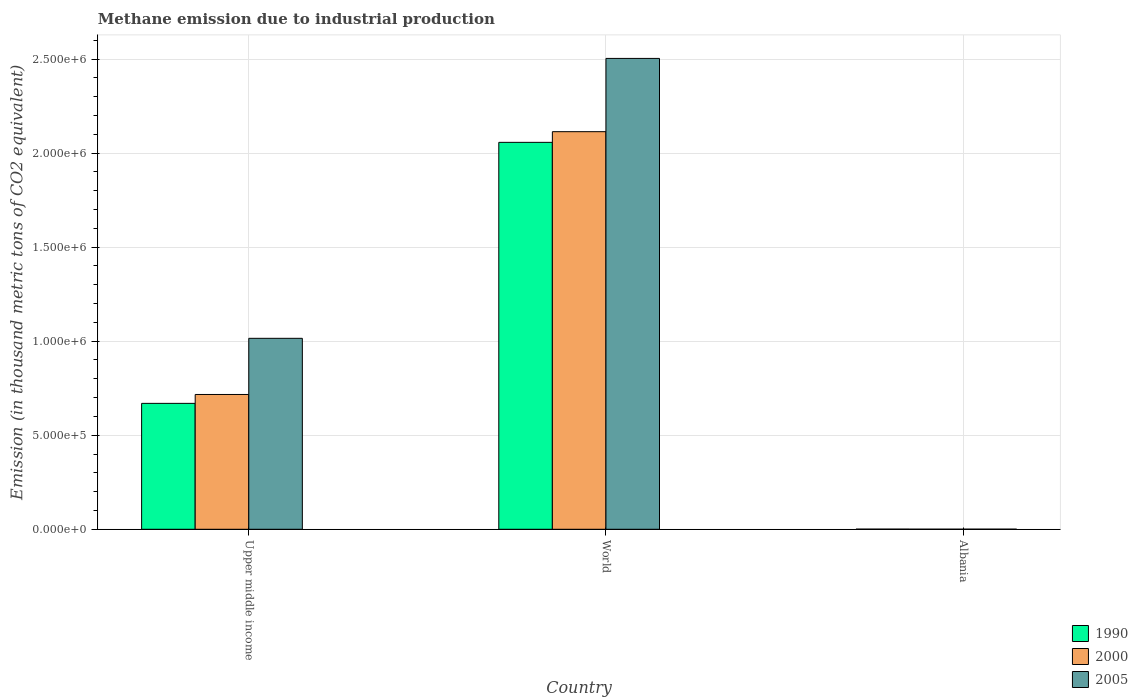How many groups of bars are there?
Keep it short and to the point. 3. How many bars are there on the 1st tick from the left?
Offer a very short reply. 3. What is the label of the 3rd group of bars from the left?
Your answer should be compact. Albania. In how many cases, is the number of bars for a given country not equal to the number of legend labels?
Provide a short and direct response. 0. What is the amount of methane emitted in 2000 in Upper middle income?
Keep it short and to the point. 7.17e+05. Across all countries, what is the maximum amount of methane emitted in 1990?
Your response must be concise. 2.06e+06. Across all countries, what is the minimum amount of methane emitted in 2005?
Your response must be concise. 550.9. In which country was the amount of methane emitted in 2000 minimum?
Give a very brief answer. Albania. What is the total amount of methane emitted in 2005 in the graph?
Your response must be concise. 3.52e+06. What is the difference between the amount of methane emitted in 2005 in Albania and that in Upper middle income?
Your answer should be very brief. -1.01e+06. What is the difference between the amount of methane emitted in 2005 in World and the amount of methane emitted in 1990 in Albania?
Your answer should be compact. 2.50e+06. What is the average amount of methane emitted in 2000 per country?
Give a very brief answer. 9.44e+05. What is the difference between the amount of methane emitted of/in 2000 and amount of methane emitted of/in 1990 in Upper middle income?
Your answer should be compact. 4.72e+04. In how many countries, is the amount of methane emitted in 1990 greater than 800000 thousand metric tons?
Provide a short and direct response. 1. What is the ratio of the amount of methane emitted in 1990 in Upper middle income to that in World?
Provide a short and direct response. 0.33. Is the amount of methane emitted in 2005 in Albania less than that in Upper middle income?
Provide a succinct answer. Yes. Is the difference between the amount of methane emitted in 2000 in Albania and World greater than the difference between the amount of methane emitted in 1990 in Albania and World?
Your answer should be compact. No. What is the difference between the highest and the second highest amount of methane emitted in 2000?
Your answer should be compact. -2.11e+06. What is the difference between the highest and the lowest amount of methane emitted in 2005?
Give a very brief answer. 2.50e+06. What does the 2nd bar from the right in World represents?
Offer a very short reply. 2000. Is it the case that in every country, the sum of the amount of methane emitted in 1990 and amount of methane emitted in 2000 is greater than the amount of methane emitted in 2005?
Make the answer very short. Yes. Are all the bars in the graph horizontal?
Ensure brevity in your answer.  No. Does the graph contain any zero values?
Your response must be concise. No. Where does the legend appear in the graph?
Keep it short and to the point. Bottom right. How are the legend labels stacked?
Ensure brevity in your answer.  Vertical. What is the title of the graph?
Ensure brevity in your answer.  Methane emission due to industrial production. What is the label or title of the X-axis?
Your response must be concise. Country. What is the label or title of the Y-axis?
Provide a short and direct response. Emission (in thousand metric tons of CO2 equivalent). What is the Emission (in thousand metric tons of CO2 equivalent) of 1990 in Upper middle income?
Your answer should be compact. 6.69e+05. What is the Emission (in thousand metric tons of CO2 equivalent) of 2000 in Upper middle income?
Provide a short and direct response. 7.17e+05. What is the Emission (in thousand metric tons of CO2 equivalent) of 2005 in Upper middle income?
Your answer should be compact. 1.02e+06. What is the Emission (in thousand metric tons of CO2 equivalent) of 1990 in World?
Make the answer very short. 2.06e+06. What is the Emission (in thousand metric tons of CO2 equivalent) in 2000 in World?
Offer a terse response. 2.11e+06. What is the Emission (in thousand metric tons of CO2 equivalent) of 2005 in World?
Offer a very short reply. 2.50e+06. What is the Emission (in thousand metric tons of CO2 equivalent) in 1990 in Albania?
Provide a short and direct response. 789.5. What is the Emission (in thousand metric tons of CO2 equivalent) in 2000 in Albania?
Offer a very short reply. 383.4. What is the Emission (in thousand metric tons of CO2 equivalent) of 2005 in Albania?
Your answer should be compact. 550.9. Across all countries, what is the maximum Emission (in thousand metric tons of CO2 equivalent) of 1990?
Your answer should be very brief. 2.06e+06. Across all countries, what is the maximum Emission (in thousand metric tons of CO2 equivalent) of 2000?
Ensure brevity in your answer.  2.11e+06. Across all countries, what is the maximum Emission (in thousand metric tons of CO2 equivalent) of 2005?
Provide a short and direct response. 2.50e+06. Across all countries, what is the minimum Emission (in thousand metric tons of CO2 equivalent) in 1990?
Your response must be concise. 789.5. Across all countries, what is the minimum Emission (in thousand metric tons of CO2 equivalent) of 2000?
Your response must be concise. 383.4. Across all countries, what is the minimum Emission (in thousand metric tons of CO2 equivalent) of 2005?
Your response must be concise. 550.9. What is the total Emission (in thousand metric tons of CO2 equivalent) of 1990 in the graph?
Give a very brief answer. 2.73e+06. What is the total Emission (in thousand metric tons of CO2 equivalent) of 2000 in the graph?
Offer a terse response. 2.83e+06. What is the total Emission (in thousand metric tons of CO2 equivalent) of 2005 in the graph?
Give a very brief answer. 3.52e+06. What is the difference between the Emission (in thousand metric tons of CO2 equivalent) of 1990 in Upper middle income and that in World?
Your response must be concise. -1.39e+06. What is the difference between the Emission (in thousand metric tons of CO2 equivalent) of 2000 in Upper middle income and that in World?
Ensure brevity in your answer.  -1.40e+06. What is the difference between the Emission (in thousand metric tons of CO2 equivalent) in 2005 in Upper middle income and that in World?
Provide a short and direct response. -1.49e+06. What is the difference between the Emission (in thousand metric tons of CO2 equivalent) of 1990 in Upper middle income and that in Albania?
Ensure brevity in your answer.  6.69e+05. What is the difference between the Emission (in thousand metric tons of CO2 equivalent) of 2000 in Upper middle income and that in Albania?
Provide a short and direct response. 7.16e+05. What is the difference between the Emission (in thousand metric tons of CO2 equivalent) of 2005 in Upper middle income and that in Albania?
Your response must be concise. 1.01e+06. What is the difference between the Emission (in thousand metric tons of CO2 equivalent) of 1990 in World and that in Albania?
Keep it short and to the point. 2.06e+06. What is the difference between the Emission (in thousand metric tons of CO2 equivalent) of 2000 in World and that in Albania?
Provide a succinct answer. 2.11e+06. What is the difference between the Emission (in thousand metric tons of CO2 equivalent) of 2005 in World and that in Albania?
Give a very brief answer. 2.50e+06. What is the difference between the Emission (in thousand metric tons of CO2 equivalent) of 1990 in Upper middle income and the Emission (in thousand metric tons of CO2 equivalent) of 2000 in World?
Offer a very short reply. -1.44e+06. What is the difference between the Emission (in thousand metric tons of CO2 equivalent) in 1990 in Upper middle income and the Emission (in thousand metric tons of CO2 equivalent) in 2005 in World?
Your answer should be very brief. -1.83e+06. What is the difference between the Emission (in thousand metric tons of CO2 equivalent) of 2000 in Upper middle income and the Emission (in thousand metric tons of CO2 equivalent) of 2005 in World?
Provide a short and direct response. -1.79e+06. What is the difference between the Emission (in thousand metric tons of CO2 equivalent) of 1990 in Upper middle income and the Emission (in thousand metric tons of CO2 equivalent) of 2000 in Albania?
Offer a very short reply. 6.69e+05. What is the difference between the Emission (in thousand metric tons of CO2 equivalent) in 1990 in Upper middle income and the Emission (in thousand metric tons of CO2 equivalent) in 2005 in Albania?
Provide a short and direct response. 6.69e+05. What is the difference between the Emission (in thousand metric tons of CO2 equivalent) in 2000 in Upper middle income and the Emission (in thousand metric tons of CO2 equivalent) in 2005 in Albania?
Your answer should be very brief. 7.16e+05. What is the difference between the Emission (in thousand metric tons of CO2 equivalent) of 1990 in World and the Emission (in thousand metric tons of CO2 equivalent) of 2000 in Albania?
Offer a very short reply. 2.06e+06. What is the difference between the Emission (in thousand metric tons of CO2 equivalent) in 1990 in World and the Emission (in thousand metric tons of CO2 equivalent) in 2005 in Albania?
Make the answer very short. 2.06e+06. What is the difference between the Emission (in thousand metric tons of CO2 equivalent) of 2000 in World and the Emission (in thousand metric tons of CO2 equivalent) of 2005 in Albania?
Provide a succinct answer. 2.11e+06. What is the average Emission (in thousand metric tons of CO2 equivalent) in 1990 per country?
Your response must be concise. 9.09e+05. What is the average Emission (in thousand metric tons of CO2 equivalent) of 2000 per country?
Give a very brief answer. 9.44e+05. What is the average Emission (in thousand metric tons of CO2 equivalent) of 2005 per country?
Offer a very short reply. 1.17e+06. What is the difference between the Emission (in thousand metric tons of CO2 equivalent) in 1990 and Emission (in thousand metric tons of CO2 equivalent) in 2000 in Upper middle income?
Provide a short and direct response. -4.72e+04. What is the difference between the Emission (in thousand metric tons of CO2 equivalent) of 1990 and Emission (in thousand metric tons of CO2 equivalent) of 2005 in Upper middle income?
Give a very brief answer. -3.46e+05. What is the difference between the Emission (in thousand metric tons of CO2 equivalent) of 2000 and Emission (in thousand metric tons of CO2 equivalent) of 2005 in Upper middle income?
Provide a succinct answer. -2.99e+05. What is the difference between the Emission (in thousand metric tons of CO2 equivalent) of 1990 and Emission (in thousand metric tons of CO2 equivalent) of 2000 in World?
Keep it short and to the point. -5.67e+04. What is the difference between the Emission (in thousand metric tons of CO2 equivalent) in 1990 and Emission (in thousand metric tons of CO2 equivalent) in 2005 in World?
Ensure brevity in your answer.  -4.46e+05. What is the difference between the Emission (in thousand metric tons of CO2 equivalent) in 2000 and Emission (in thousand metric tons of CO2 equivalent) in 2005 in World?
Your answer should be very brief. -3.90e+05. What is the difference between the Emission (in thousand metric tons of CO2 equivalent) of 1990 and Emission (in thousand metric tons of CO2 equivalent) of 2000 in Albania?
Ensure brevity in your answer.  406.1. What is the difference between the Emission (in thousand metric tons of CO2 equivalent) of 1990 and Emission (in thousand metric tons of CO2 equivalent) of 2005 in Albania?
Your answer should be very brief. 238.6. What is the difference between the Emission (in thousand metric tons of CO2 equivalent) of 2000 and Emission (in thousand metric tons of CO2 equivalent) of 2005 in Albania?
Give a very brief answer. -167.5. What is the ratio of the Emission (in thousand metric tons of CO2 equivalent) of 1990 in Upper middle income to that in World?
Your answer should be very brief. 0.33. What is the ratio of the Emission (in thousand metric tons of CO2 equivalent) of 2000 in Upper middle income to that in World?
Offer a very short reply. 0.34. What is the ratio of the Emission (in thousand metric tons of CO2 equivalent) in 2005 in Upper middle income to that in World?
Make the answer very short. 0.41. What is the ratio of the Emission (in thousand metric tons of CO2 equivalent) in 1990 in Upper middle income to that in Albania?
Ensure brevity in your answer.  847.92. What is the ratio of the Emission (in thousand metric tons of CO2 equivalent) in 2000 in Upper middle income to that in Albania?
Ensure brevity in your answer.  1869.27. What is the ratio of the Emission (in thousand metric tons of CO2 equivalent) of 2005 in Upper middle income to that in Albania?
Provide a short and direct response. 1842.83. What is the ratio of the Emission (in thousand metric tons of CO2 equivalent) of 1990 in World to that in Albania?
Provide a succinct answer. 2605.63. What is the ratio of the Emission (in thousand metric tons of CO2 equivalent) of 2000 in World to that in Albania?
Provide a short and direct response. 5513.42. What is the ratio of the Emission (in thousand metric tons of CO2 equivalent) in 2005 in World to that in Albania?
Your answer should be very brief. 4544.17. What is the difference between the highest and the second highest Emission (in thousand metric tons of CO2 equivalent) of 1990?
Make the answer very short. 1.39e+06. What is the difference between the highest and the second highest Emission (in thousand metric tons of CO2 equivalent) in 2000?
Your response must be concise. 1.40e+06. What is the difference between the highest and the second highest Emission (in thousand metric tons of CO2 equivalent) in 2005?
Offer a terse response. 1.49e+06. What is the difference between the highest and the lowest Emission (in thousand metric tons of CO2 equivalent) of 1990?
Your answer should be very brief. 2.06e+06. What is the difference between the highest and the lowest Emission (in thousand metric tons of CO2 equivalent) in 2000?
Your answer should be compact. 2.11e+06. What is the difference between the highest and the lowest Emission (in thousand metric tons of CO2 equivalent) of 2005?
Offer a terse response. 2.50e+06. 